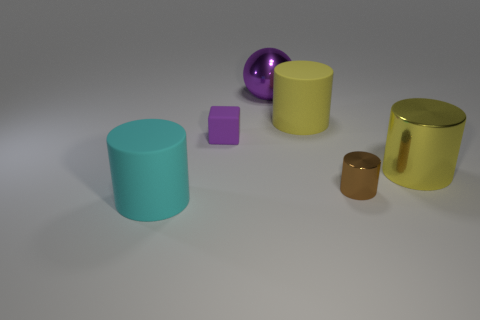There is a large yellow thing that is to the left of the yellow cylinder in front of the small rubber thing; is there a big purple shiny sphere that is right of it?
Your answer should be compact. No. Is the number of yellow matte cylinders less than the number of small cyan matte cylinders?
Provide a succinct answer. No. Is the shape of the big yellow object behind the matte cube the same as  the purple rubber object?
Your answer should be compact. No. Is there a large brown ball?
Your answer should be very brief. No. What color is the metallic object that is behind the yellow thing that is on the right side of the large rubber cylinder behind the cyan thing?
Offer a very short reply. Purple. Is the number of large things that are behind the yellow shiny cylinder the same as the number of large cyan objects that are to the left of the big ball?
Keep it short and to the point. No. The brown thing that is the same size as the purple cube is what shape?
Provide a succinct answer. Cylinder. Are there any small cubes that have the same color as the shiny ball?
Keep it short and to the point. Yes. The tiny object right of the purple ball has what shape?
Make the answer very short. Cylinder. The large metal ball has what color?
Your answer should be very brief. Purple. 